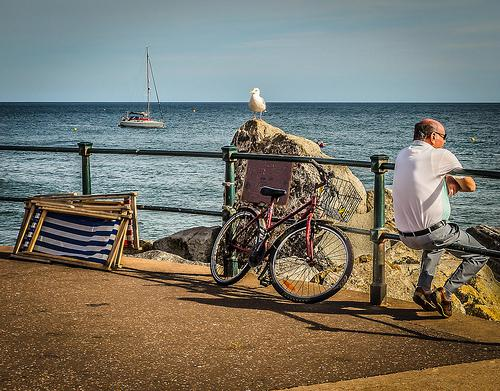Question: what color is the bike?
Choices:
A. Red.
B. White.
C. Blue.
D. Green.
Answer with the letter. Answer: A Question: what is the man sitting on?
Choices:
A. The chair.
B. The post.
C. The railing.
D. The bench.
Answer with the letter. Answer: C Question: what color are the man's trousers?
Choices:
A. Red.
B. Grey.
C. White.
D. Black.
Answer with the letter. Answer: B Question: how many animals are in the photograph?
Choices:
A. Two.
B. One.
C. Three.
D. Four.
Answer with the letter. Answer: B 